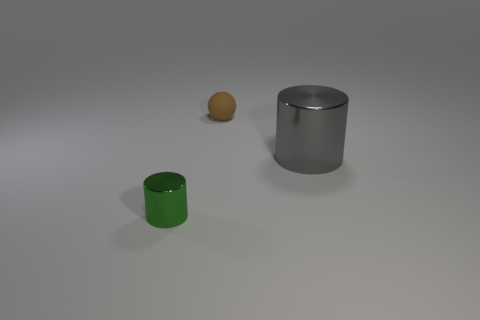What number of objects are blue rubber balls or metallic cylinders that are right of the green metal object?
Provide a short and direct response. 1. Does the metal cylinder behind the green cylinder have the same size as the small metallic object?
Provide a short and direct response. No. How many other things are there of the same size as the green shiny cylinder?
Offer a terse response. 1. What color is the large cylinder?
Your response must be concise. Gray. There is a tiny thing on the left side of the small sphere; what is its material?
Make the answer very short. Metal. Are there the same number of small rubber spheres behind the brown object and large purple cylinders?
Provide a short and direct response. Yes. Does the large gray object have the same shape as the tiny green object?
Provide a short and direct response. Yes. Is there any other thing that has the same color as the tiny metallic object?
Offer a terse response. No. What is the shape of the object that is on the right side of the green thing and on the left side of the gray object?
Provide a succinct answer. Sphere. Are there the same number of big gray metal cylinders to the left of the big gray cylinder and gray objects that are left of the tiny shiny cylinder?
Your answer should be compact. Yes. 